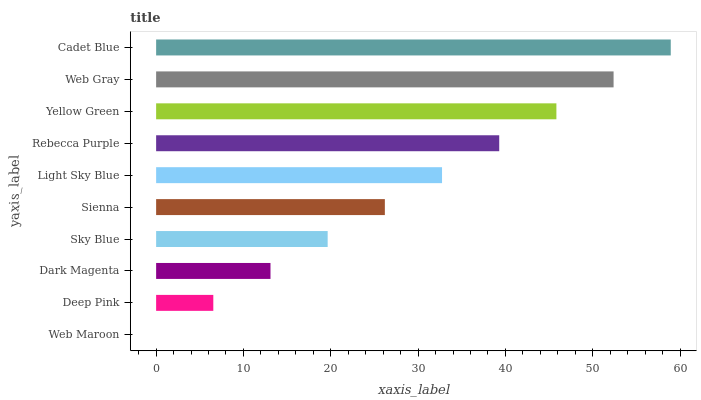Is Web Maroon the minimum?
Answer yes or no. Yes. Is Cadet Blue the maximum?
Answer yes or no. Yes. Is Deep Pink the minimum?
Answer yes or no. No. Is Deep Pink the maximum?
Answer yes or no. No. Is Deep Pink greater than Web Maroon?
Answer yes or no. Yes. Is Web Maroon less than Deep Pink?
Answer yes or no. Yes. Is Web Maroon greater than Deep Pink?
Answer yes or no. No. Is Deep Pink less than Web Maroon?
Answer yes or no. No. Is Light Sky Blue the high median?
Answer yes or no. Yes. Is Sienna the low median?
Answer yes or no. Yes. Is Deep Pink the high median?
Answer yes or no. No. Is Dark Magenta the low median?
Answer yes or no. No. 